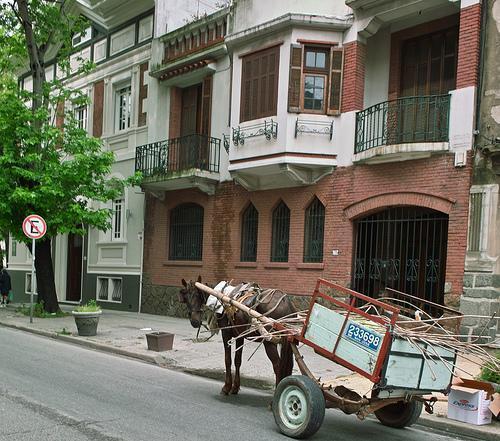How many tires are there?
Give a very brief answer. 2. How many horses are there?
Give a very brief answer. 1. How many carts are there?
Give a very brief answer. 1. How many pointed windows are there?
Give a very brief answer. 3. How many wheels does the cart have?
Give a very brief answer. 2. How many balconies are in the picture?
Give a very brief answer. 2. How many balconies are there in the picture?
Give a very brief answer. 2. How many elephants are there?
Give a very brief answer. 0. 